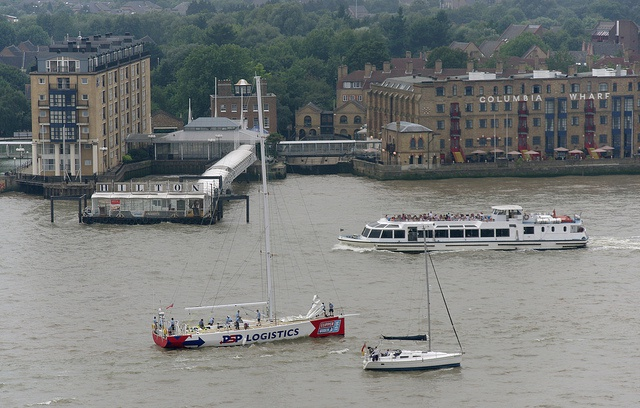Describe the objects in this image and their specific colors. I can see boat in gray, darkgray, black, and lightgray tones, boat in gray, darkgray, maroon, and black tones, people in gray, darkgray, and lightgray tones, boat in gray, darkgray, lightgray, and black tones, and people in gray, darkgray, and black tones in this image. 